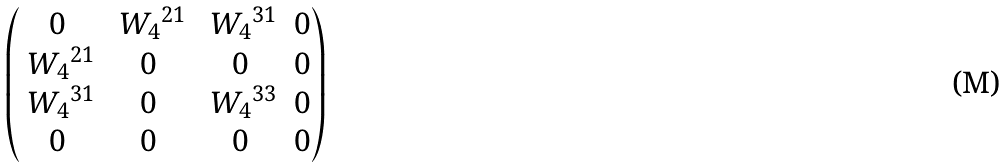<formula> <loc_0><loc_0><loc_500><loc_500>\begin{pmatrix} 0 & { \ W _ { 4 } } ^ { 2 1 } & { \ W _ { 4 } } ^ { 3 1 } & 0 \\ { \ W _ { 4 } } ^ { 2 1 } & 0 & 0 & 0 \\ { \ W _ { 4 } } ^ { 3 1 } & 0 & { \ W _ { 4 } } ^ { 3 3 } & 0 \\ 0 & 0 & 0 & 0 \end{pmatrix}</formula> 